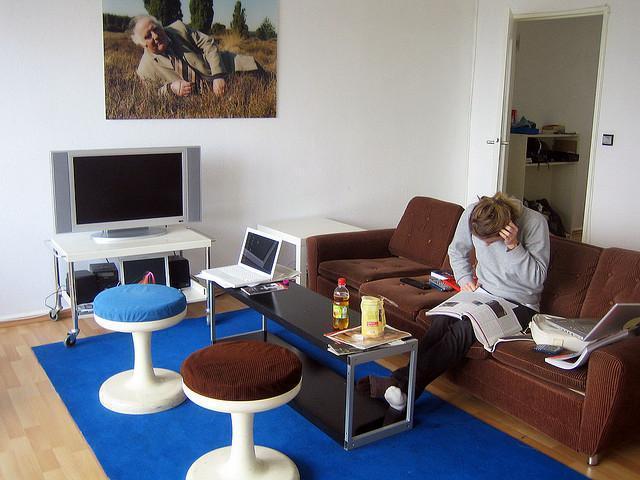How many people can you see?
Give a very brief answer. 2. How many chairs can you see?
Give a very brief answer. 4. 